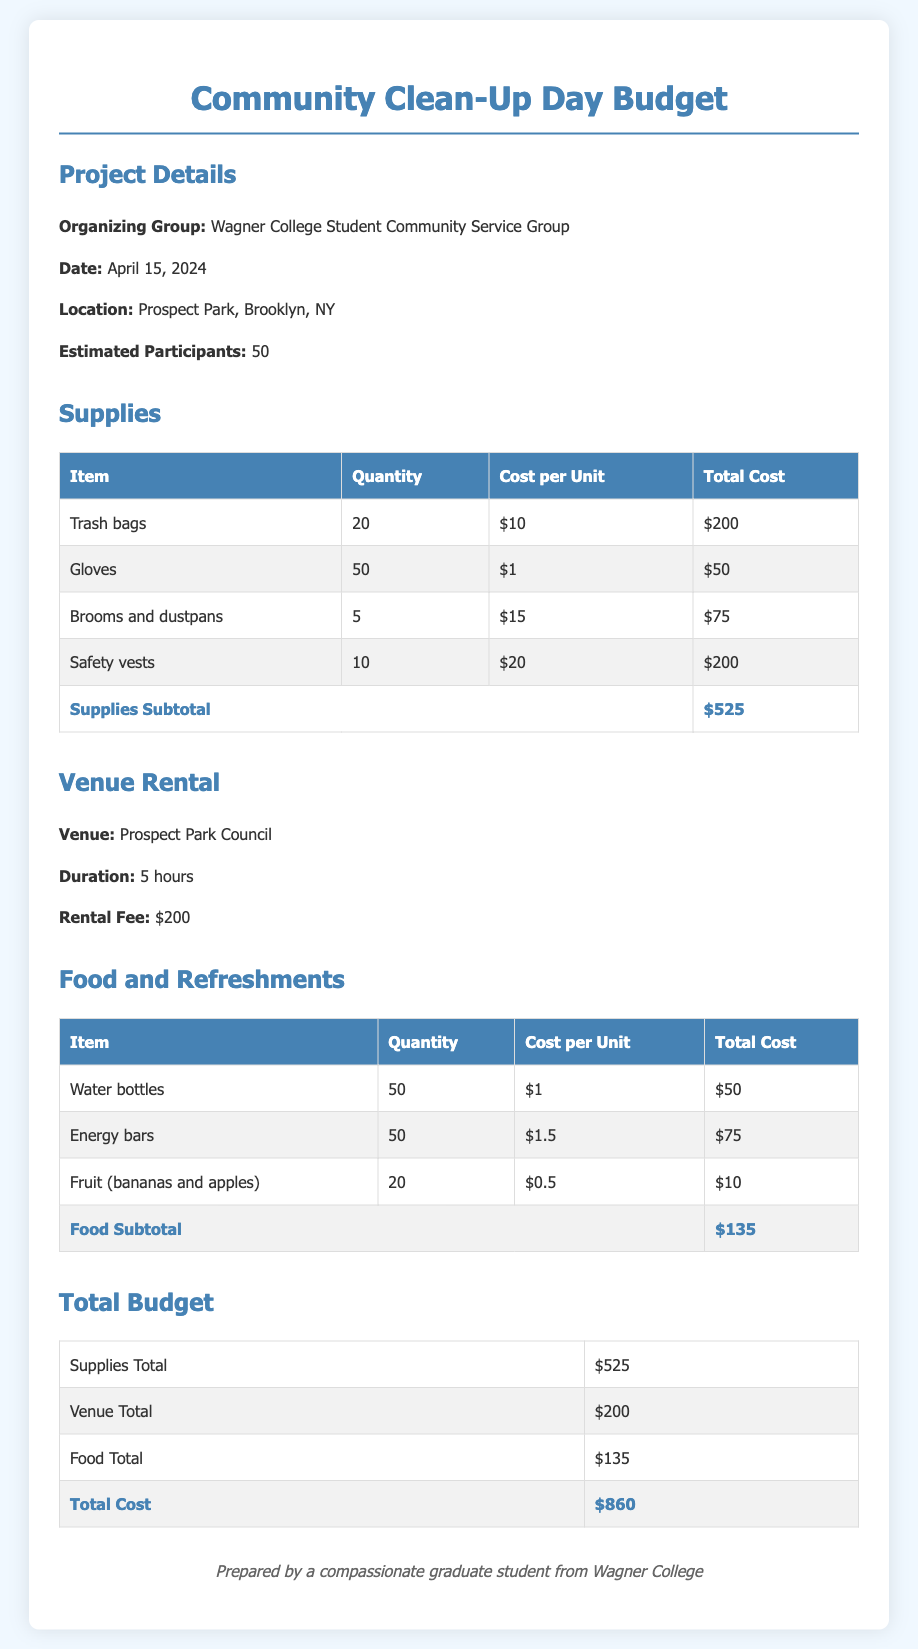what is the total cost of supplies? The total cost of supplies is listed in the document as a subtotal of various items.
Answer: $525 who organized the community service project? The document states that the organizing group is the Wagner College Student Community Service Group.
Answer: Wagner College Student Community Service Group what is the venue rental fee? The venue rental fee for Prospect Park is explicitly stated in the document.
Answer: $200 how many energy bars were purchased? The document provides a specific quantity for energy bars under the food section.
Answer: 50 what is the estimated number of participants? The document mentions the estimated number of participants for the event.
Answer: 50 what is the total cost of food and refreshments? The total cost of food is shown as a subtotal at the end of the food section.
Answer: $135 what materials are included in supplies? The document lists specific items under the supplies section, including trash bags, gloves, brooms and dustpans, and safety vests.
Answer: Trash bags, gloves, brooms and dustpans, safety vests when is the community clean-up day scheduled? The date of the community clean-up day is provided in the project details section.
Answer: April 15, 2024 